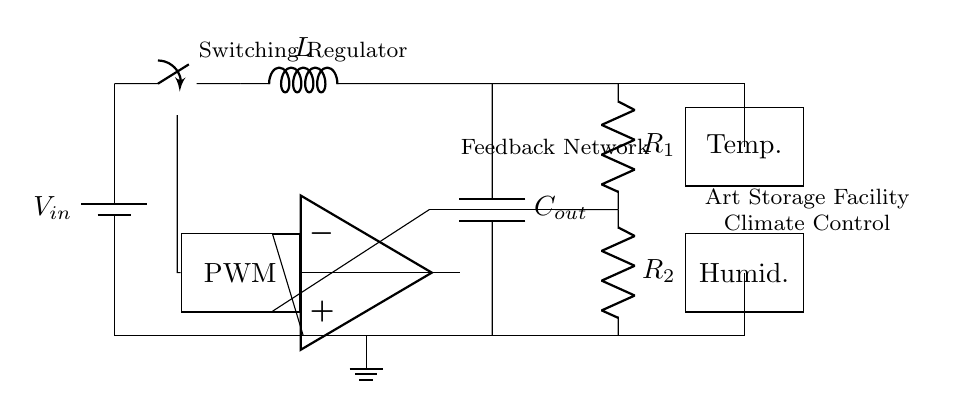What is the input voltage of the circuit? The input voltage is denoted as V in and is represented by the battery symbol at the beginning of the circuit diagram.
Answer: V in What type of components are labeled L and C out? Component L is identified as an inductor, typically used for energy storage in switching regulators, and C out is identified as an output capacitor, which smoothens the output voltage.
Answer: Inductor and Capacitor How many resistors are present in the feedback network? There are two resistors labeled R1 and R2 in the feedback network, which is used for voltage division and to provide feedback to the error amplifier.
Answer: 2 What is the purpose of the PWM controller in this circuit? The PWM controller (Pulse Width Modulation) regulates the output voltage by adjusting the width of the pulses sent to the switching elements, allowing for control of the output to meet the desired temperature and humidity levels.
Answer: Voltage regulation Which components are involved in temperature and humidity control within the circuit? The components labeled "Temp." and "Humid." are used to sense temperature and humidity respectively, providing the necessary data for the regulator to adjust outputs and maintain desired conditions.
Answer: Temp. and Humid What is the role of the op-amp in the diagram? The op-amp acts as an error amplifier, comparing the output voltage (or feedback) with a reference value to determine if adjustments are needed in the PWM signal for output control.
Answer: Error amplifier 